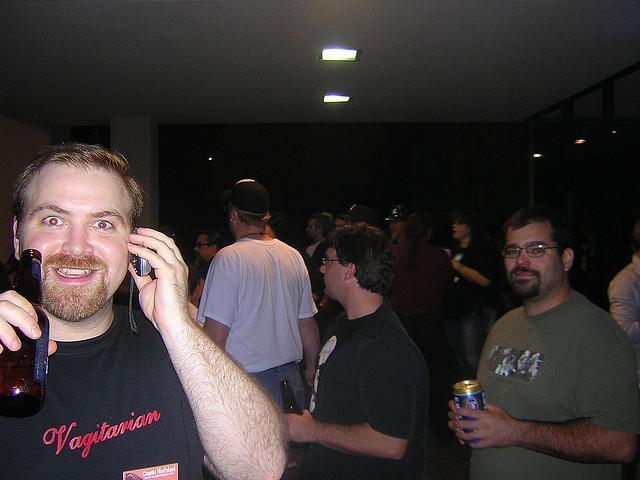How many people are there?
Give a very brief answer. 7. 